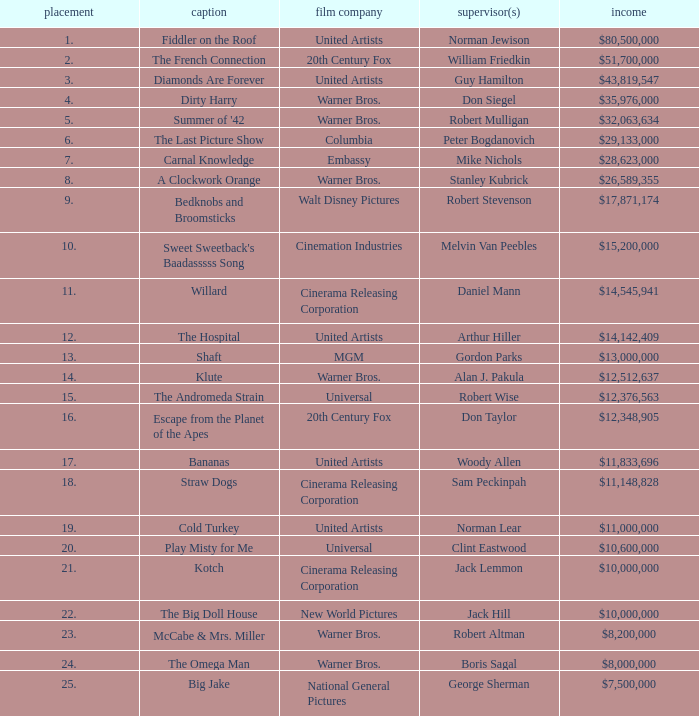What position does the title hold with a total gross of $26,589,355? 8.0. 